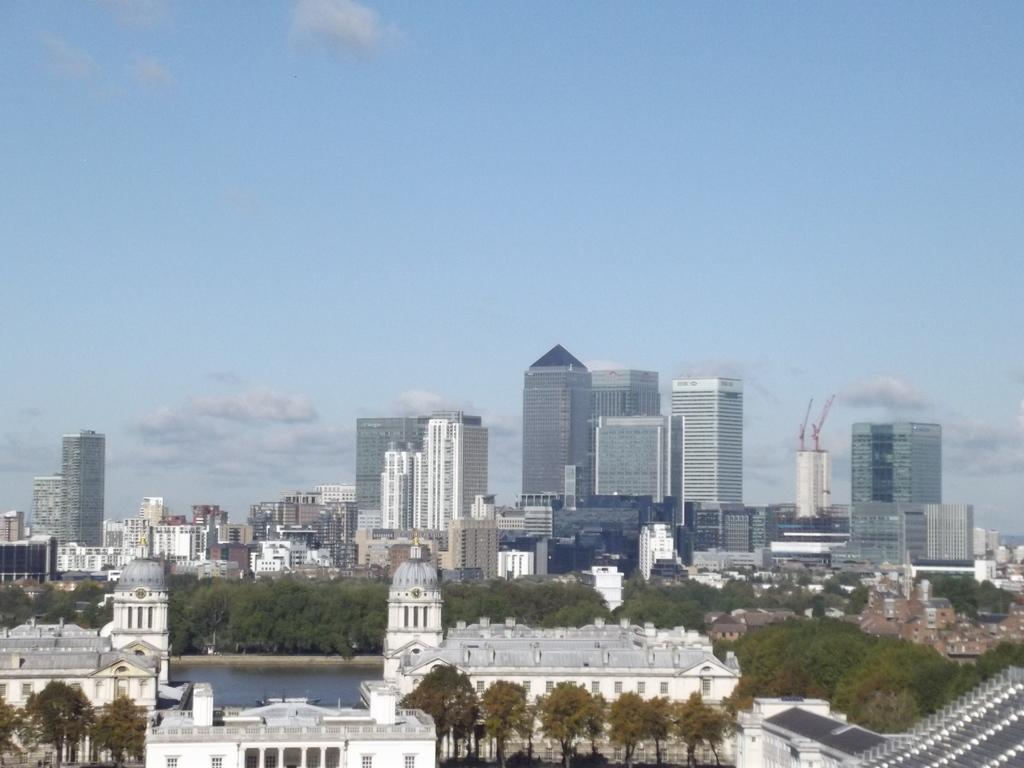What type of structures can be seen in the image? There are buildings in the image. What natural elements are present in the image? There are trees and a river in the image. What part of the natural environment is visible in the image? The sky is visible in the image. Can you describe the teaching method used by the hand in the image? There is no hand or teaching method present in the image. 